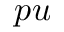<formula> <loc_0><loc_0><loc_500><loc_500>p u</formula> 